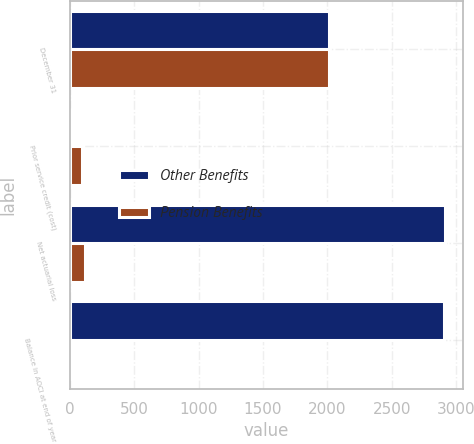<chart> <loc_0><loc_0><loc_500><loc_500><stacked_bar_chart><ecel><fcel>December 31<fcel>Prior service credit (cost)<fcel>Net actuarial loss<fcel>Balance in AOCI at end of year<nl><fcel>Other Benefits<fcel>2015<fcel>3<fcel>2910<fcel>2907<nl><fcel>Pension Benefits<fcel>2015<fcel>93<fcel>119<fcel>26<nl></chart> 